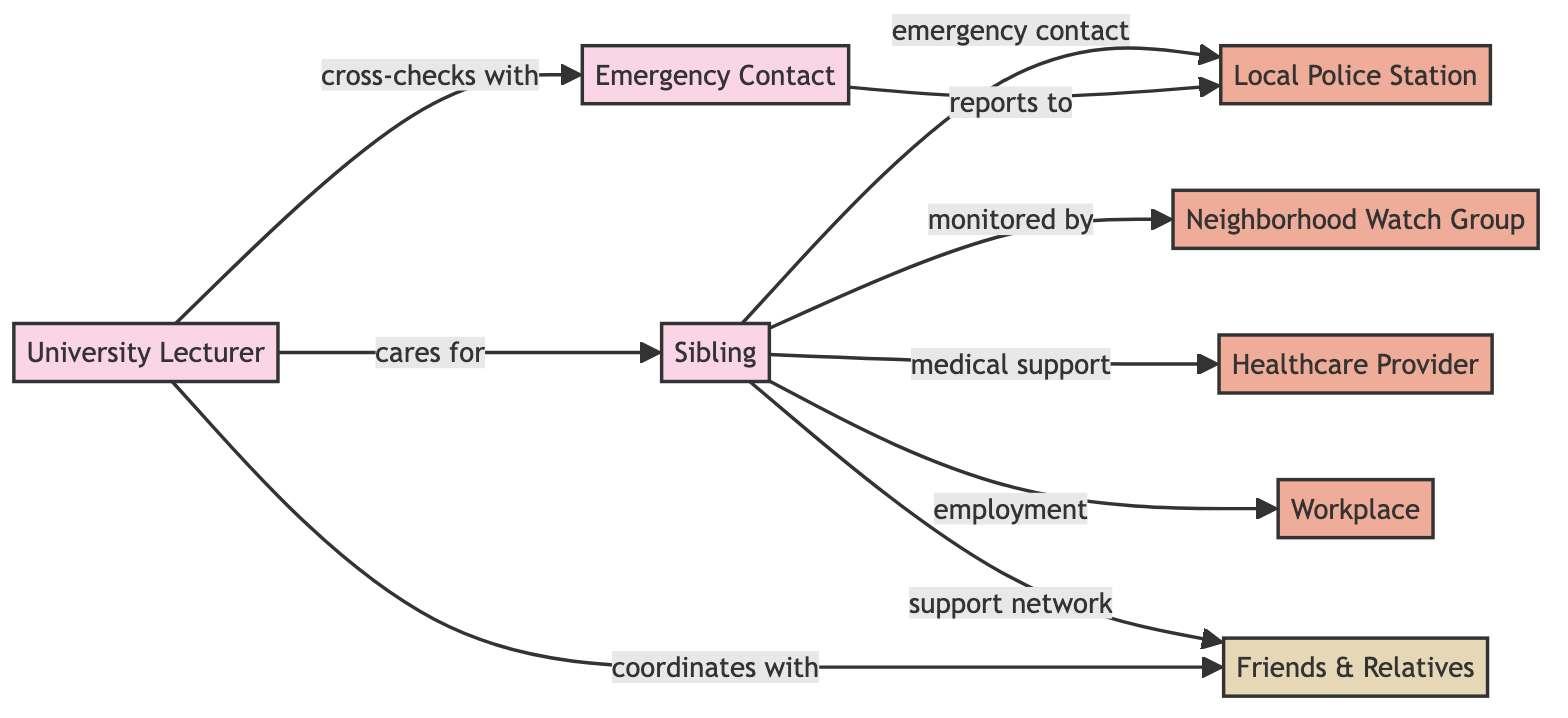What is the total number of nodes in the diagram? The diagram contains eight distinct nodes which are categorized as people, organizations, and groups. By counting each of the unique nodes presented, the total is confirmed as eight.
Answer: 8 How many organizations are present in the network? There are four nodes that are classified as organizations out of the total eight nodes. The organizations identified are Local Police Station, Neighborhood Watch Group, Healthcare Provider, and Workplace.
Answer: 4 Who does the University Lecturer care for? The diagram shows a direct relationship labeled "cares for" from the University Lecturer to the Sibling, indicating that this is the person for whom care is provided.
Answer: Sibling What type of support is the Sibling receiving from the Healthcare Provider? The diagram indicates a relationship labeled "medical support" from the Sibling to the Healthcare Provider, indicating this specific type of assistance.
Answer: medical support How does the University Lecturer coordinate with Friends & Relatives? The diagram depicts a direct connection labeled "coordinates with" from the University Lecturer to the Friends & Relatives group, which shows how they interact for support purposes.
Answer: coordinates with What is the relationship between the Sibling and the Local Police Station? The diagram indicates that the Sibling has an emergency contact relationship with the Local Police Station, reinforcing the access to security services in case of an emergency.
Answer: emergency contact Who reports to the Local Police Station? According to the diagram, the Emergency Contact is indicated to have a reporting relationship with the Local Police Station, showing the flow of information and responsibility during emergencies.
Answer: Emergency Contact Which entity provides monitoring for the Sibling? The diagram specifies that the Sibling is monitored by the Neighborhood Watch Group, highlighting local protection and observation capabilities.
Answer: Neighborhood Watch Group What type of group is Friends & Relatives classified as? The diagram categorizes Friends & Relatives as a group, distinguishing it from individual persons or organizations and showing collective support.
Answer: group 